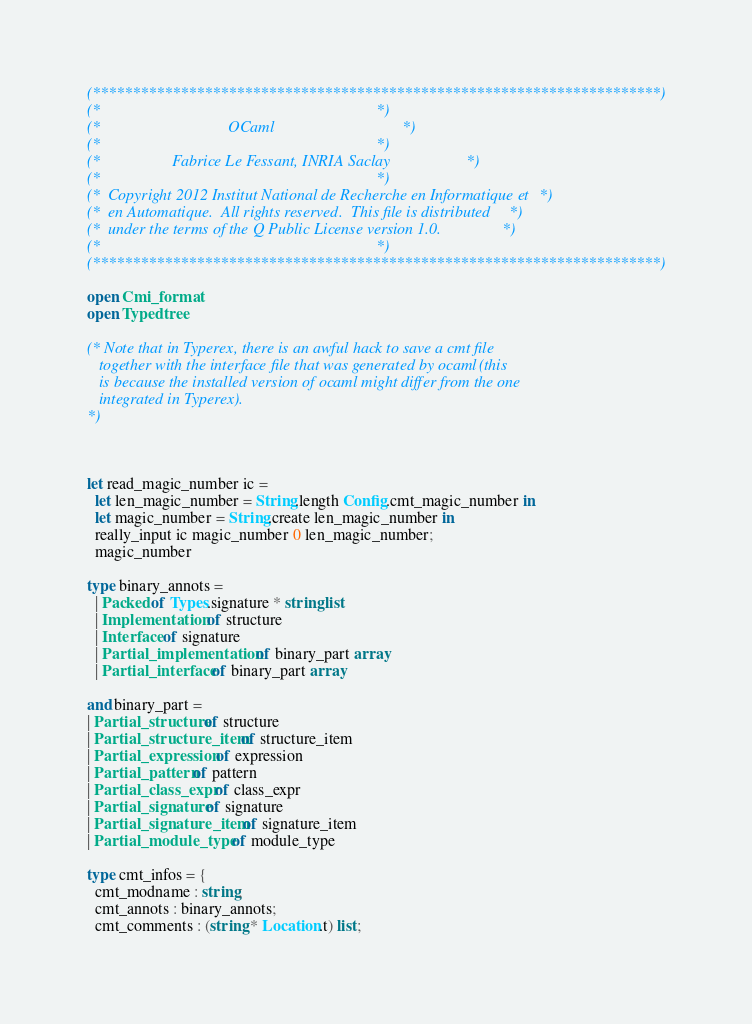<code> <loc_0><loc_0><loc_500><loc_500><_OCaml_>(***********************************************************************)
(*                                                                     *)
(*                                OCaml                                *)
(*                                                                     *)
(*                  Fabrice Le Fessant, INRIA Saclay                   *)
(*                                                                     *)
(*  Copyright 2012 Institut National de Recherche en Informatique et   *)
(*  en Automatique.  All rights reserved.  This file is distributed    *)
(*  under the terms of the Q Public License version 1.0.               *)
(*                                                                     *)
(***********************************************************************)

open Cmi_format
open Typedtree

(* Note that in Typerex, there is an awful hack to save a cmt file
   together with the interface file that was generated by ocaml (this
   is because the installed version of ocaml might differ from the one
   integrated in Typerex).
*)



let read_magic_number ic =
  let len_magic_number = String.length Config.cmt_magic_number in
  let magic_number = String.create len_magic_number in
  really_input ic magic_number 0 len_magic_number;
  magic_number

type binary_annots =
  | Packed of Types.signature * string list
  | Implementation of structure
  | Interface of signature
  | Partial_implementation of binary_part array
  | Partial_interface of binary_part array

and binary_part =
| Partial_structure of structure
| Partial_structure_item of structure_item
| Partial_expression of expression
| Partial_pattern of pattern
| Partial_class_expr of class_expr
| Partial_signature of signature
| Partial_signature_item of signature_item
| Partial_module_type of module_type

type cmt_infos = {
  cmt_modname : string;
  cmt_annots : binary_annots;
  cmt_comments : (string * Location.t) list;</code> 